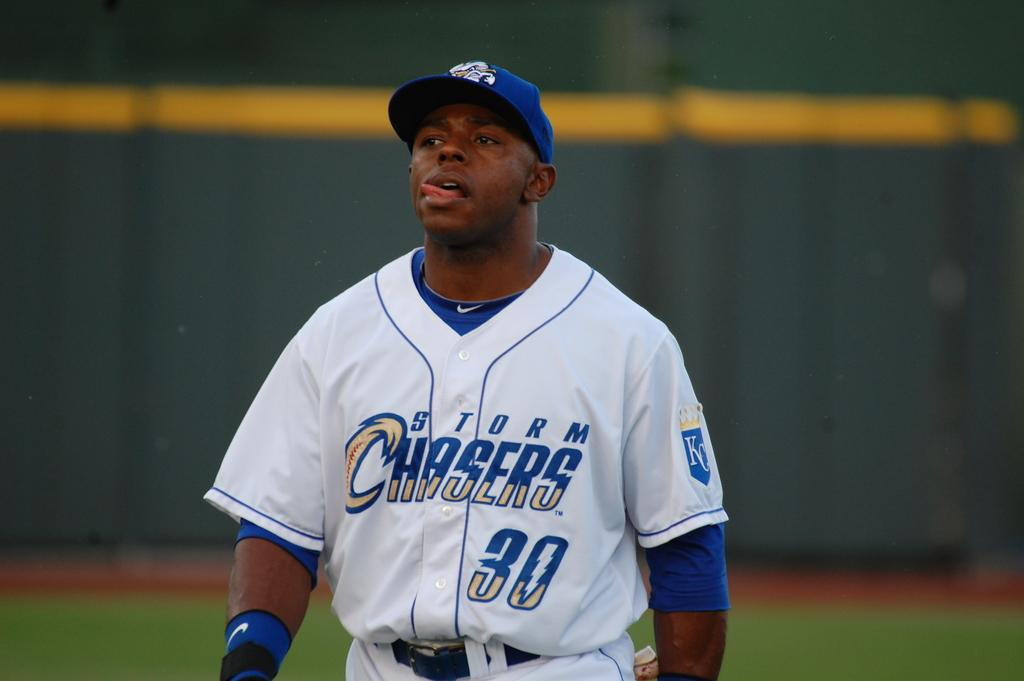<image>
Give a short and clear explanation of the subsequent image. a man in a Storm Chasers 30 jersey sticks out his tongue 